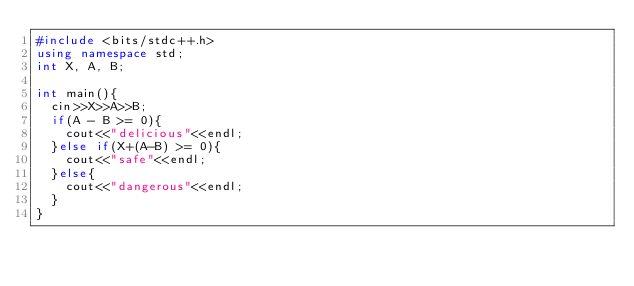Convert code to text. <code><loc_0><loc_0><loc_500><loc_500><_C++_>#include <bits/stdc++.h>
using namespace std;
int X, A, B;

int main(){
  cin>>X>>A>>B;
  if(A - B >= 0){
    cout<<"delicious"<<endl;
  }else if(X+(A-B) >= 0){
    cout<<"safe"<<endl;
  }else{
    cout<<"dangerous"<<endl;
  }
}</code> 